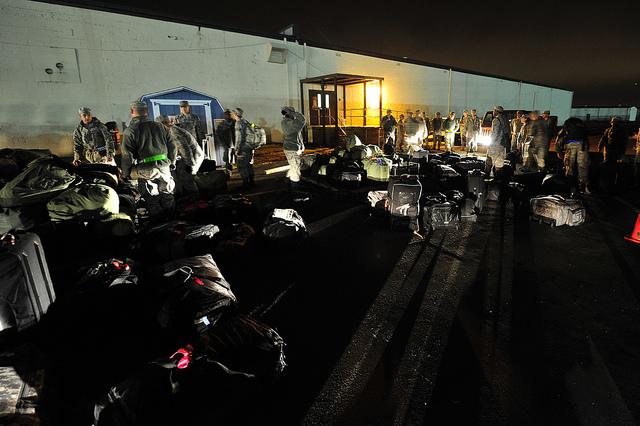What time of day is this taking place?
Answer briefly. Night. Is there luggage in this picture?
Short answer required. Yes. Why are there so many bags?
Answer briefly. Customs. What color is the floor?
Quick response, please. Black. 